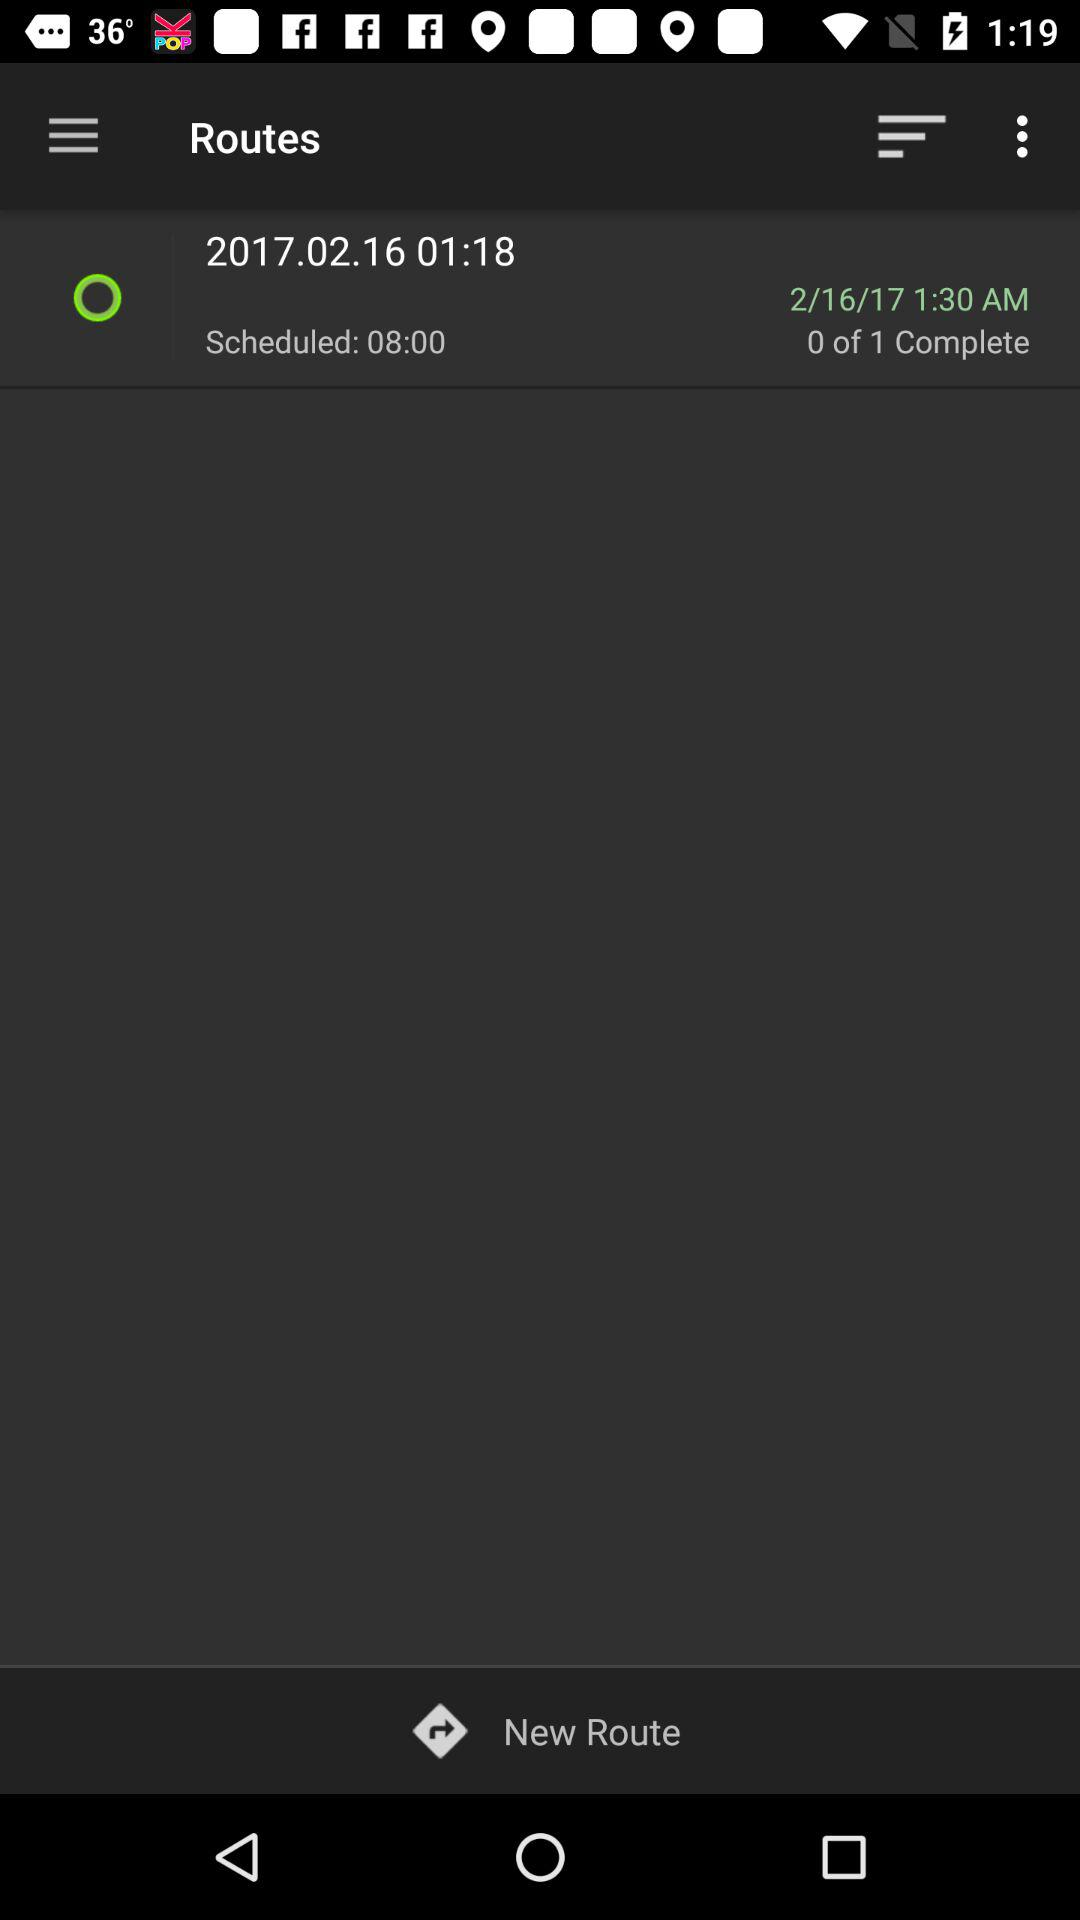What is the scheduled time? The scheduled time is 8:00. 